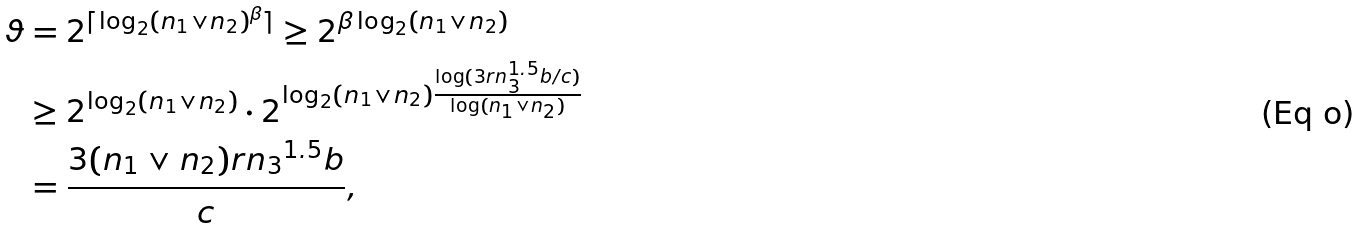Convert formula to latex. <formula><loc_0><loc_0><loc_500><loc_500>\vartheta & = 2 ^ { \lceil \log _ { 2 } ( n _ { 1 } \vee n _ { 2 } ) ^ { \beta } \rceil } \geq 2 ^ { \beta \log _ { 2 } ( n _ { 1 } \vee n _ { 2 } ) } \\ & \geq 2 ^ { \log _ { 2 } ( n _ { 1 } \vee n _ { 2 } ) } \cdot 2 ^ { \log _ { 2 } ( n _ { 1 } \vee n _ { 2 } ) \frac { \log ( 3 r n _ { 3 } ^ { 1 . 5 } b / c ) } { \log ( n _ { 1 } \vee n _ { 2 } ) } } \\ & = \frac { 3 ( n _ { 1 } \vee n _ { 2 } ) r { n _ { 3 } } ^ { 1 . 5 } b } { c } ,</formula> 